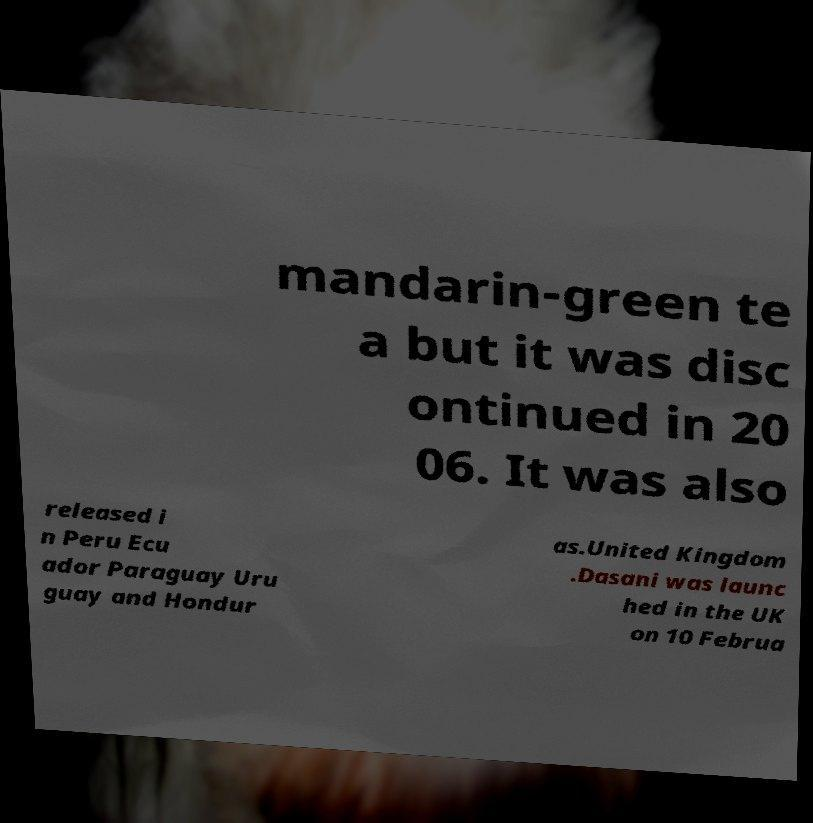Could you extract and type out the text from this image? mandarin-green te a but it was disc ontinued in 20 06. It was also released i n Peru Ecu ador Paraguay Uru guay and Hondur as.United Kingdom .Dasani was launc hed in the UK on 10 Februa 